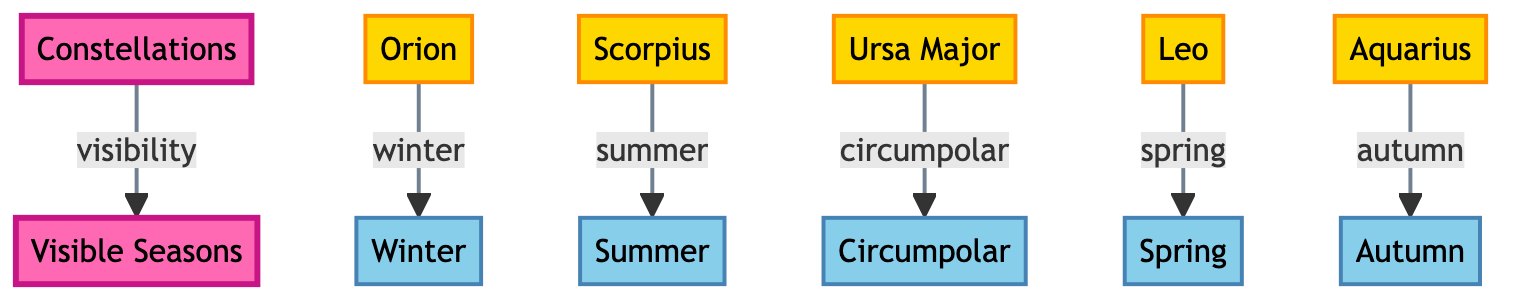What constellations are visible in winter? The diagram shows the constellation Orion connected to the season Winter. Therefore, the only constellation that is marked visible in winter is Orion.
Answer: Orion How many constellations are listed in the diagram? The diagram contains five constellations: Orion, Scorpius, Ursa Major, Leo, and Aquarius. Counting these gives a total of five.
Answer: 5 Which constellation is visible in summer? The diagram indicates that the constellation Scorpius is connected to the season Summer. Thus, Scorpius is the constellation visible in summer.
Answer: Scorpius What season is associated with the constellation Leo? According to the connections shown in the diagram, Leo is associated with the season Spring. Therefore, the answer is Spring.
Answer: Spring Are there any constellations that are visible year-round? The diagram specifies that Ursa Major is labeled as circumpolar, which means it is visible year-round. Hence, Ursa Major is the constellation visible all year.
Answer: Ursa Major How many seasons are depicted in the diagram? The diagram shows five distinct seasons: Winter, Spring, Summer, Autumn, and Circumpolar. This counts as five seasons in total.
Answer: 5 Which constellation appears in autumn? The diagram links the constellation Aquarius with the season Autumn. This indicates that Aquarius is the constellation visible in autumn.
Answer: Aquarius What is the relationship between constellations and seasons in the diagram? The diagram illustrates that each constellation is associated with one specific season of visibility, meaning each constellation is linked to a unique seasonal period.
Answer: One-to-one relationship 